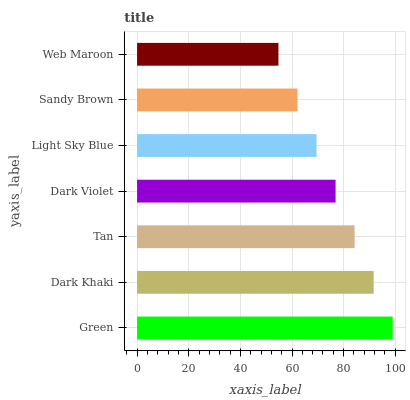Is Web Maroon the minimum?
Answer yes or no. Yes. Is Green the maximum?
Answer yes or no. Yes. Is Dark Khaki the minimum?
Answer yes or no. No. Is Dark Khaki the maximum?
Answer yes or no. No. Is Green greater than Dark Khaki?
Answer yes or no. Yes. Is Dark Khaki less than Green?
Answer yes or no. Yes. Is Dark Khaki greater than Green?
Answer yes or no. No. Is Green less than Dark Khaki?
Answer yes or no. No. Is Dark Violet the high median?
Answer yes or no. Yes. Is Dark Violet the low median?
Answer yes or no. Yes. Is Green the high median?
Answer yes or no. No. Is Sandy Brown the low median?
Answer yes or no. No. 